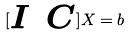<formula> <loc_0><loc_0><loc_500><loc_500>[ \begin{matrix} I & C \end{matrix} ] X = b</formula> 